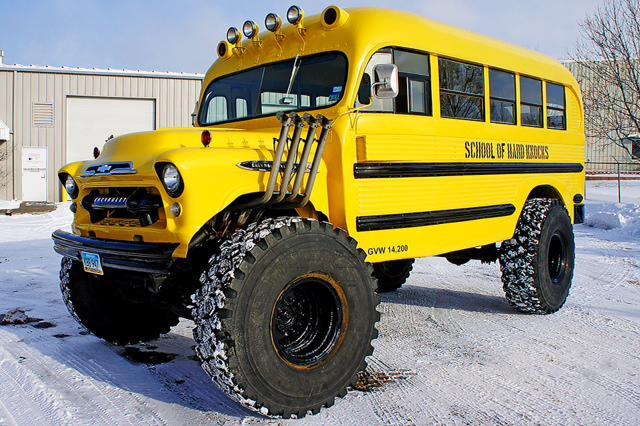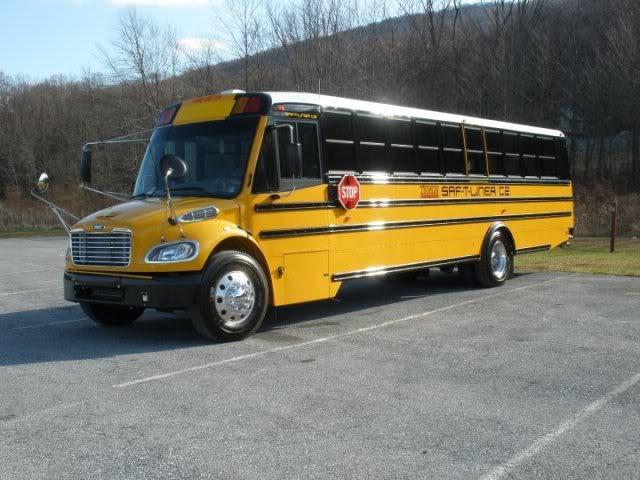The first image is the image on the left, the second image is the image on the right. Considering the images on both sides, is "A bus' left side is visible." valid? Answer yes or no. Yes. The first image is the image on the left, the second image is the image on the right. Assess this claim about the two images: "The combined images show two buses heading in the same direction with a shorter bus appearing to be leading.". Correct or not? Answer yes or no. Yes. 